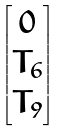<formula> <loc_0><loc_0><loc_500><loc_500>\begin{bmatrix} 0 \\ T _ { 6 } \\ T _ { 9 } \end{bmatrix}</formula> 